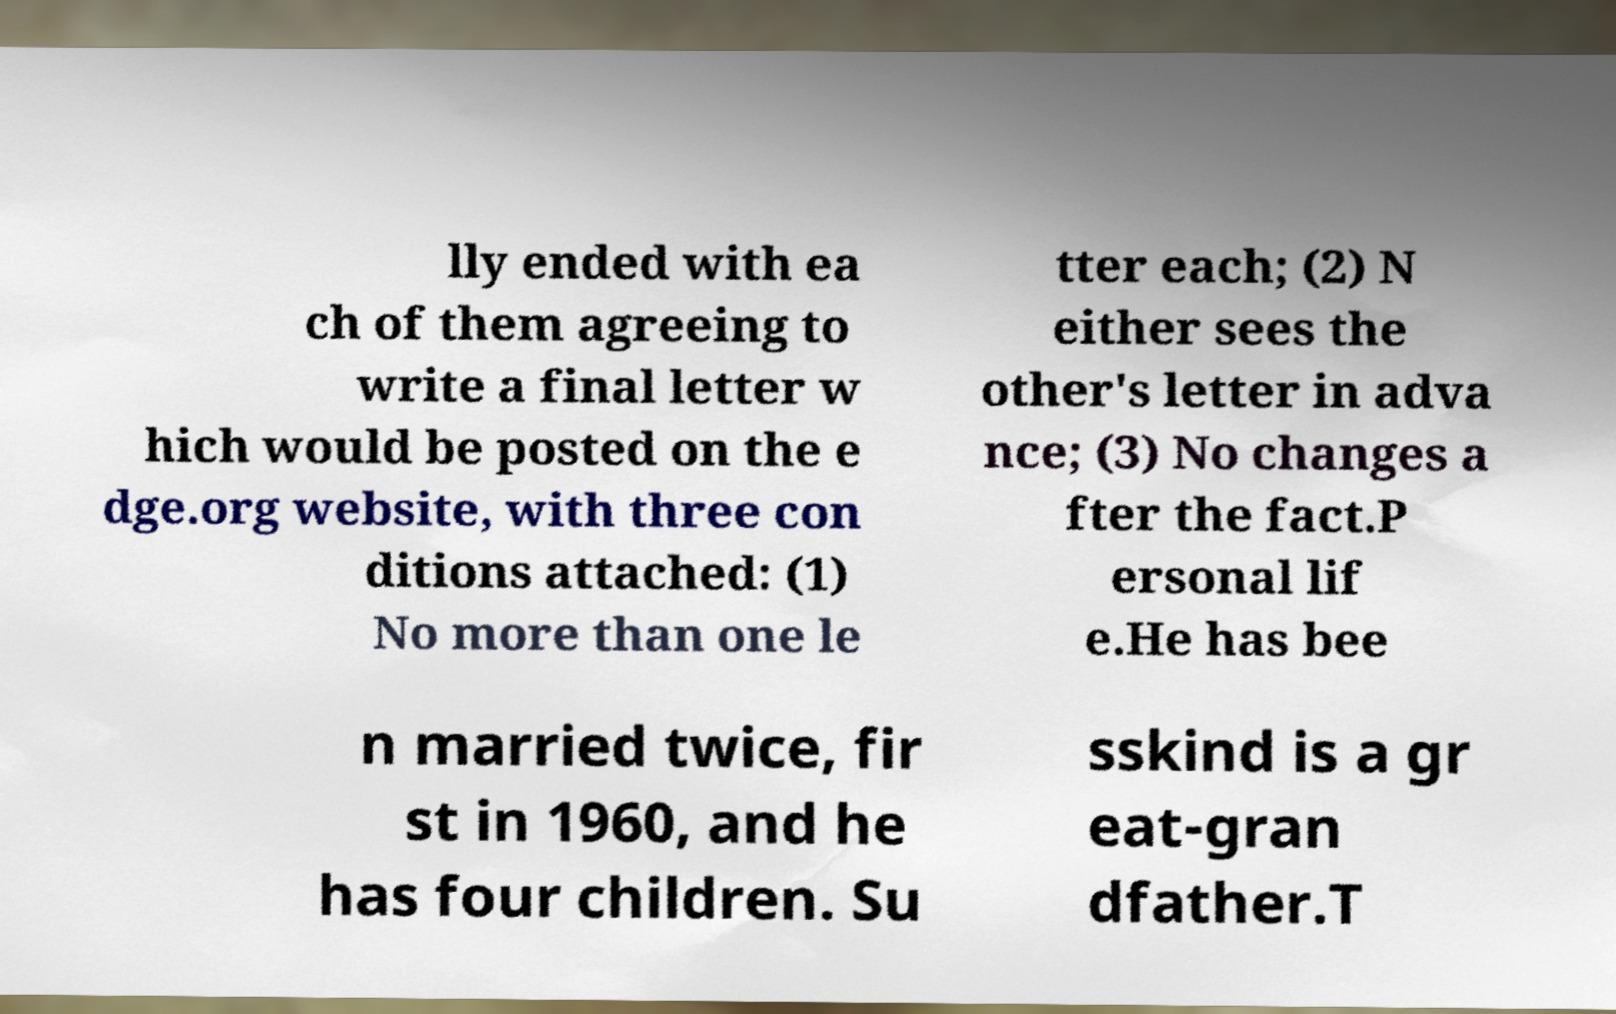Can you accurately transcribe the text from the provided image for me? lly ended with ea ch of them agreeing to write a final letter w hich would be posted on the e dge.org website, with three con ditions attached: (1) No more than one le tter each; (2) N either sees the other's letter in adva nce; (3) No changes a fter the fact.P ersonal lif e.He has bee n married twice, fir st in 1960, and he has four children. Su sskind is a gr eat-gran dfather.T 